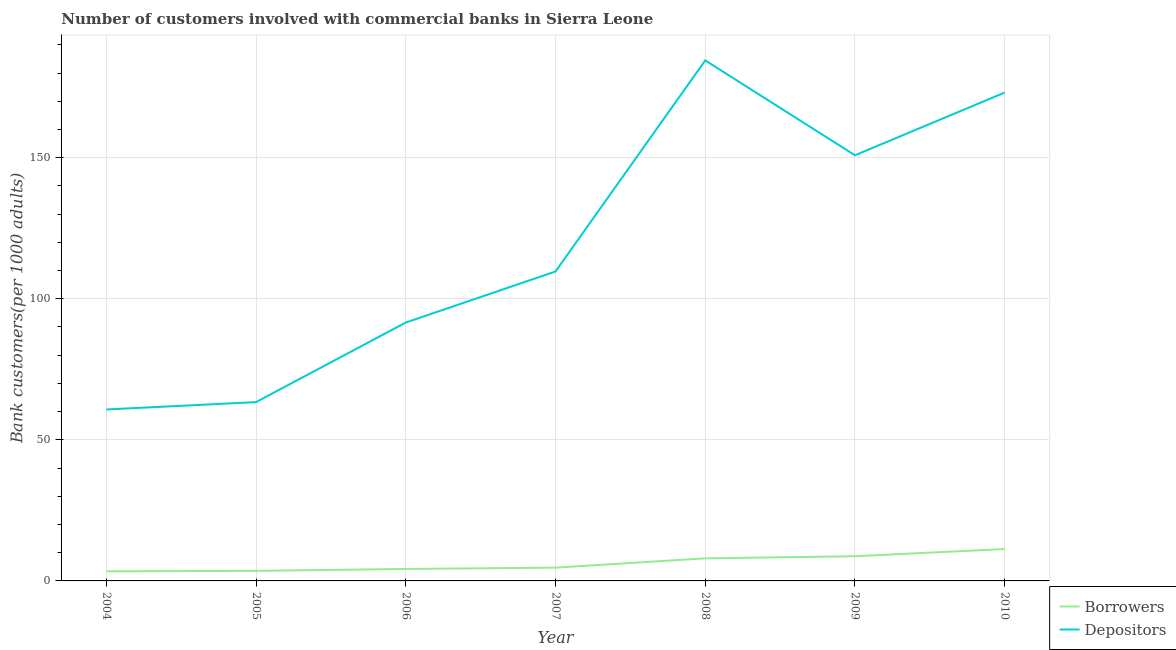Is the number of lines equal to the number of legend labels?
Your answer should be very brief. Yes. What is the number of depositors in 2004?
Your answer should be very brief. 60.76. Across all years, what is the maximum number of borrowers?
Your answer should be compact. 11.3. Across all years, what is the minimum number of depositors?
Keep it short and to the point. 60.76. In which year was the number of borrowers maximum?
Your answer should be compact. 2010. What is the total number of borrowers in the graph?
Your answer should be compact. 43.96. What is the difference between the number of borrowers in 2008 and that in 2009?
Give a very brief answer. -0.76. What is the difference between the number of borrowers in 2006 and the number of depositors in 2007?
Ensure brevity in your answer.  -105.42. What is the average number of borrowers per year?
Your answer should be very brief. 6.28. In the year 2007, what is the difference between the number of depositors and number of borrowers?
Keep it short and to the point. 104.96. In how many years, is the number of depositors greater than 60?
Keep it short and to the point. 7. What is the ratio of the number of borrowers in 2005 to that in 2007?
Give a very brief answer. 0.76. Is the number of depositors in 2004 less than that in 2007?
Offer a very short reply. Yes. What is the difference between the highest and the second highest number of borrowers?
Your answer should be compact. 2.54. What is the difference between the highest and the lowest number of borrowers?
Offer a very short reply. 7.9. Does the number of depositors monotonically increase over the years?
Make the answer very short. No. What is the difference between two consecutive major ticks on the Y-axis?
Your answer should be compact. 50. Are the values on the major ticks of Y-axis written in scientific E-notation?
Offer a very short reply. No. Does the graph contain grids?
Give a very brief answer. Yes. How are the legend labels stacked?
Your answer should be compact. Vertical. What is the title of the graph?
Your answer should be very brief. Number of customers involved with commercial banks in Sierra Leone. Does "Taxes on profits and capital gains" appear as one of the legend labels in the graph?
Your answer should be compact. No. What is the label or title of the Y-axis?
Make the answer very short. Bank customers(per 1000 adults). What is the Bank customers(per 1000 adults) in Borrowers in 2004?
Your answer should be compact. 3.4. What is the Bank customers(per 1000 adults) in Depositors in 2004?
Keep it short and to the point. 60.76. What is the Bank customers(per 1000 adults) of Borrowers in 2005?
Keep it short and to the point. 3.56. What is the Bank customers(per 1000 adults) of Depositors in 2005?
Offer a very short reply. 63.37. What is the Bank customers(per 1000 adults) of Borrowers in 2006?
Offer a terse response. 4.24. What is the Bank customers(per 1000 adults) of Depositors in 2006?
Offer a terse response. 91.57. What is the Bank customers(per 1000 adults) in Borrowers in 2007?
Your answer should be compact. 4.71. What is the Bank customers(per 1000 adults) of Depositors in 2007?
Offer a terse response. 109.66. What is the Bank customers(per 1000 adults) of Borrowers in 2008?
Provide a succinct answer. 7.99. What is the Bank customers(per 1000 adults) of Depositors in 2008?
Offer a very short reply. 184.46. What is the Bank customers(per 1000 adults) of Borrowers in 2009?
Give a very brief answer. 8.75. What is the Bank customers(per 1000 adults) of Depositors in 2009?
Offer a terse response. 150.85. What is the Bank customers(per 1000 adults) in Borrowers in 2010?
Your response must be concise. 11.3. What is the Bank customers(per 1000 adults) in Depositors in 2010?
Your response must be concise. 173.07. Across all years, what is the maximum Bank customers(per 1000 adults) of Borrowers?
Offer a terse response. 11.3. Across all years, what is the maximum Bank customers(per 1000 adults) of Depositors?
Make the answer very short. 184.46. Across all years, what is the minimum Bank customers(per 1000 adults) in Borrowers?
Make the answer very short. 3.4. Across all years, what is the minimum Bank customers(per 1000 adults) in Depositors?
Provide a short and direct response. 60.76. What is the total Bank customers(per 1000 adults) in Borrowers in the graph?
Ensure brevity in your answer.  43.96. What is the total Bank customers(per 1000 adults) in Depositors in the graph?
Your answer should be compact. 833.74. What is the difference between the Bank customers(per 1000 adults) of Borrowers in 2004 and that in 2005?
Provide a succinct answer. -0.16. What is the difference between the Bank customers(per 1000 adults) of Depositors in 2004 and that in 2005?
Provide a short and direct response. -2.6. What is the difference between the Bank customers(per 1000 adults) of Borrowers in 2004 and that in 2006?
Make the answer very short. -0.84. What is the difference between the Bank customers(per 1000 adults) in Depositors in 2004 and that in 2006?
Keep it short and to the point. -30.81. What is the difference between the Bank customers(per 1000 adults) in Borrowers in 2004 and that in 2007?
Your answer should be compact. -1.3. What is the difference between the Bank customers(per 1000 adults) in Depositors in 2004 and that in 2007?
Give a very brief answer. -48.9. What is the difference between the Bank customers(per 1000 adults) of Borrowers in 2004 and that in 2008?
Your answer should be very brief. -4.59. What is the difference between the Bank customers(per 1000 adults) in Depositors in 2004 and that in 2008?
Give a very brief answer. -123.7. What is the difference between the Bank customers(per 1000 adults) of Borrowers in 2004 and that in 2009?
Keep it short and to the point. -5.35. What is the difference between the Bank customers(per 1000 adults) in Depositors in 2004 and that in 2009?
Your response must be concise. -90.08. What is the difference between the Bank customers(per 1000 adults) of Borrowers in 2004 and that in 2010?
Your response must be concise. -7.9. What is the difference between the Bank customers(per 1000 adults) in Depositors in 2004 and that in 2010?
Offer a terse response. -112.31. What is the difference between the Bank customers(per 1000 adults) of Borrowers in 2005 and that in 2006?
Ensure brevity in your answer.  -0.68. What is the difference between the Bank customers(per 1000 adults) of Depositors in 2005 and that in 2006?
Make the answer very short. -28.2. What is the difference between the Bank customers(per 1000 adults) in Borrowers in 2005 and that in 2007?
Provide a succinct answer. -1.14. What is the difference between the Bank customers(per 1000 adults) of Depositors in 2005 and that in 2007?
Your answer should be compact. -46.3. What is the difference between the Bank customers(per 1000 adults) of Borrowers in 2005 and that in 2008?
Offer a very short reply. -4.43. What is the difference between the Bank customers(per 1000 adults) in Depositors in 2005 and that in 2008?
Give a very brief answer. -121.1. What is the difference between the Bank customers(per 1000 adults) in Borrowers in 2005 and that in 2009?
Your answer should be very brief. -5.19. What is the difference between the Bank customers(per 1000 adults) of Depositors in 2005 and that in 2009?
Your response must be concise. -87.48. What is the difference between the Bank customers(per 1000 adults) of Borrowers in 2005 and that in 2010?
Make the answer very short. -7.73. What is the difference between the Bank customers(per 1000 adults) in Depositors in 2005 and that in 2010?
Offer a terse response. -109.7. What is the difference between the Bank customers(per 1000 adults) in Borrowers in 2006 and that in 2007?
Provide a short and direct response. -0.47. What is the difference between the Bank customers(per 1000 adults) of Depositors in 2006 and that in 2007?
Provide a short and direct response. -18.09. What is the difference between the Bank customers(per 1000 adults) in Borrowers in 2006 and that in 2008?
Your response must be concise. -3.75. What is the difference between the Bank customers(per 1000 adults) in Depositors in 2006 and that in 2008?
Ensure brevity in your answer.  -92.89. What is the difference between the Bank customers(per 1000 adults) of Borrowers in 2006 and that in 2009?
Make the answer very short. -4.51. What is the difference between the Bank customers(per 1000 adults) of Depositors in 2006 and that in 2009?
Your answer should be very brief. -59.28. What is the difference between the Bank customers(per 1000 adults) in Borrowers in 2006 and that in 2010?
Provide a short and direct response. -7.06. What is the difference between the Bank customers(per 1000 adults) in Depositors in 2006 and that in 2010?
Offer a terse response. -81.5. What is the difference between the Bank customers(per 1000 adults) of Borrowers in 2007 and that in 2008?
Provide a short and direct response. -3.29. What is the difference between the Bank customers(per 1000 adults) in Depositors in 2007 and that in 2008?
Offer a terse response. -74.8. What is the difference between the Bank customers(per 1000 adults) of Borrowers in 2007 and that in 2009?
Your response must be concise. -4.05. What is the difference between the Bank customers(per 1000 adults) of Depositors in 2007 and that in 2009?
Your response must be concise. -41.18. What is the difference between the Bank customers(per 1000 adults) of Borrowers in 2007 and that in 2010?
Provide a short and direct response. -6.59. What is the difference between the Bank customers(per 1000 adults) in Depositors in 2007 and that in 2010?
Make the answer very short. -63.41. What is the difference between the Bank customers(per 1000 adults) of Borrowers in 2008 and that in 2009?
Ensure brevity in your answer.  -0.76. What is the difference between the Bank customers(per 1000 adults) of Depositors in 2008 and that in 2009?
Provide a succinct answer. 33.62. What is the difference between the Bank customers(per 1000 adults) in Borrowers in 2008 and that in 2010?
Your response must be concise. -3.3. What is the difference between the Bank customers(per 1000 adults) in Depositors in 2008 and that in 2010?
Provide a succinct answer. 11.39. What is the difference between the Bank customers(per 1000 adults) in Borrowers in 2009 and that in 2010?
Provide a succinct answer. -2.54. What is the difference between the Bank customers(per 1000 adults) in Depositors in 2009 and that in 2010?
Your response must be concise. -22.22. What is the difference between the Bank customers(per 1000 adults) of Borrowers in 2004 and the Bank customers(per 1000 adults) of Depositors in 2005?
Offer a terse response. -59.96. What is the difference between the Bank customers(per 1000 adults) in Borrowers in 2004 and the Bank customers(per 1000 adults) in Depositors in 2006?
Your answer should be compact. -88.17. What is the difference between the Bank customers(per 1000 adults) in Borrowers in 2004 and the Bank customers(per 1000 adults) in Depositors in 2007?
Offer a very short reply. -106.26. What is the difference between the Bank customers(per 1000 adults) in Borrowers in 2004 and the Bank customers(per 1000 adults) in Depositors in 2008?
Your response must be concise. -181.06. What is the difference between the Bank customers(per 1000 adults) of Borrowers in 2004 and the Bank customers(per 1000 adults) of Depositors in 2009?
Give a very brief answer. -147.44. What is the difference between the Bank customers(per 1000 adults) of Borrowers in 2004 and the Bank customers(per 1000 adults) of Depositors in 2010?
Your answer should be compact. -169.67. What is the difference between the Bank customers(per 1000 adults) of Borrowers in 2005 and the Bank customers(per 1000 adults) of Depositors in 2006?
Keep it short and to the point. -88. What is the difference between the Bank customers(per 1000 adults) in Borrowers in 2005 and the Bank customers(per 1000 adults) in Depositors in 2007?
Your response must be concise. -106.1. What is the difference between the Bank customers(per 1000 adults) in Borrowers in 2005 and the Bank customers(per 1000 adults) in Depositors in 2008?
Your answer should be compact. -180.9. What is the difference between the Bank customers(per 1000 adults) in Borrowers in 2005 and the Bank customers(per 1000 adults) in Depositors in 2009?
Make the answer very short. -147.28. What is the difference between the Bank customers(per 1000 adults) in Borrowers in 2005 and the Bank customers(per 1000 adults) in Depositors in 2010?
Keep it short and to the point. -169.5. What is the difference between the Bank customers(per 1000 adults) in Borrowers in 2006 and the Bank customers(per 1000 adults) in Depositors in 2007?
Provide a short and direct response. -105.42. What is the difference between the Bank customers(per 1000 adults) in Borrowers in 2006 and the Bank customers(per 1000 adults) in Depositors in 2008?
Give a very brief answer. -180.22. What is the difference between the Bank customers(per 1000 adults) in Borrowers in 2006 and the Bank customers(per 1000 adults) in Depositors in 2009?
Your answer should be compact. -146.61. What is the difference between the Bank customers(per 1000 adults) in Borrowers in 2006 and the Bank customers(per 1000 adults) in Depositors in 2010?
Provide a short and direct response. -168.83. What is the difference between the Bank customers(per 1000 adults) in Borrowers in 2007 and the Bank customers(per 1000 adults) in Depositors in 2008?
Offer a very short reply. -179.76. What is the difference between the Bank customers(per 1000 adults) in Borrowers in 2007 and the Bank customers(per 1000 adults) in Depositors in 2009?
Offer a terse response. -146.14. What is the difference between the Bank customers(per 1000 adults) in Borrowers in 2007 and the Bank customers(per 1000 adults) in Depositors in 2010?
Offer a terse response. -168.36. What is the difference between the Bank customers(per 1000 adults) of Borrowers in 2008 and the Bank customers(per 1000 adults) of Depositors in 2009?
Your answer should be compact. -142.85. What is the difference between the Bank customers(per 1000 adults) in Borrowers in 2008 and the Bank customers(per 1000 adults) in Depositors in 2010?
Your response must be concise. -165.08. What is the difference between the Bank customers(per 1000 adults) of Borrowers in 2009 and the Bank customers(per 1000 adults) of Depositors in 2010?
Provide a succinct answer. -164.32. What is the average Bank customers(per 1000 adults) of Borrowers per year?
Provide a succinct answer. 6.28. What is the average Bank customers(per 1000 adults) of Depositors per year?
Provide a short and direct response. 119.11. In the year 2004, what is the difference between the Bank customers(per 1000 adults) in Borrowers and Bank customers(per 1000 adults) in Depositors?
Give a very brief answer. -57.36. In the year 2005, what is the difference between the Bank customers(per 1000 adults) of Borrowers and Bank customers(per 1000 adults) of Depositors?
Ensure brevity in your answer.  -59.8. In the year 2006, what is the difference between the Bank customers(per 1000 adults) in Borrowers and Bank customers(per 1000 adults) in Depositors?
Give a very brief answer. -87.33. In the year 2007, what is the difference between the Bank customers(per 1000 adults) of Borrowers and Bank customers(per 1000 adults) of Depositors?
Provide a short and direct response. -104.96. In the year 2008, what is the difference between the Bank customers(per 1000 adults) of Borrowers and Bank customers(per 1000 adults) of Depositors?
Give a very brief answer. -176.47. In the year 2009, what is the difference between the Bank customers(per 1000 adults) in Borrowers and Bank customers(per 1000 adults) in Depositors?
Provide a succinct answer. -142.09. In the year 2010, what is the difference between the Bank customers(per 1000 adults) of Borrowers and Bank customers(per 1000 adults) of Depositors?
Give a very brief answer. -161.77. What is the ratio of the Bank customers(per 1000 adults) of Borrowers in 2004 to that in 2005?
Your answer should be compact. 0.95. What is the ratio of the Bank customers(per 1000 adults) in Depositors in 2004 to that in 2005?
Keep it short and to the point. 0.96. What is the ratio of the Bank customers(per 1000 adults) of Borrowers in 2004 to that in 2006?
Give a very brief answer. 0.8. What is the ratio of the Bank customers(per 1000 adults) of Depositors in 2004 to that in 2006?
Give a very brief answer. 0.66. What is the ratio of the Bank customers(per 1000 adults) in Borrowers in 2004 to that in 2007?
Keep it short and to the point. 0.72. What is the ratio of the Bank customers(per 1000 adults) of Depositors in 2004 to that in 2007?
Provide a short and direct response. 0.55. What is the ratio of the Bank customers(per 1000 adults) of Borrowers in 2004 to that in 2008?
Give a very brief answer. 0.43. What is the ratio of the Bank customers(per 1000 adults) of Depositors in 2004 to that in 2008?
Offer a very short reply. 0.33. What is the ratio of the Bank customers(per 1000 adults) of Borrowers in 2004 to that in 2009?
Give a very brief answer. 0.39. What is the ratio of the Bank customers(per 1000 adults) in Depositors in 2004 to that in 2009?
Offer a terse response. 0.4. What is the ratio of the Bank customers(per 1000 adults) of Borrowers in 2004 to that in 2010?
Provide a succinct answer. 0.3. What is the ratio of the Bank customers(per 1000 adults) of Depositors in 2004 to that in 2010?
Offer a very short reply. 0.35. What is the ratio of the Bank customers(per 1000 adults) in Borrowers in 2005 to that in 2006?
Your response must be concise. 0.84. What is the ratio of the Bank customers(per 1000 adults) in Depositors in 2005 to that in 2006?
Provide a succinct answer. 0.69. What is the ratio of the Bank customers(per 1000 adults) of Borrowers in 2005 to that in 2007?
Your answer should be very brief. 0.76. What is the ratio of the Bank customers(per 1000 adults) of Depositors in 2005 to that in 2007?
Your answer should be compact. 0.58. What is the ratio of the Bank customers(per 1000 adults) of Borrowers in 2005 to that in 2008?
Provide a short and direct response. 0.45. What is the ratio of the Bank customers(per 1000 adults) of Depositors in 2005 to that in 2008?
Ensure brevity in your answer.  0.34. What is the ratio of the Bank customers(per 1000 adults) of Borrowers in 2005 to that in 2009?
Offer a terse response. 0.41. What is the ratio of the Bank customers(per 1000 adults) of Depositors in 2005 to that in 2009?
Keep it short and to the point. 0.42. What is the ratio of the Bank customers(per 1000 adults) in Borrowers in 2005 to that in 2010?
Give a very brief answer. 0.32. What is the ratio of the Bank customers(per 1000 adults) in Depositors in 2005 to that in 2010?
Offer a very short reply. 0.37. What is the ratio of the Bank customers(per 1000 adults) in Borrowers in 2006 to that in 2007?
Keep it short and to the point. 0.9. What is the ratio of the Bank customers(per 1000 adults) of Depositors in 2006 to that in 2007?
Offer a very short reply. 0.83. What is the ratio of the Bank customers(per 1000 adults) of Borrowers in 2006 to that in 2008?
Your response must be concise. 0.53. What is the ratio of the Bank customers(per 1000 adults) in Depositors in 2006 to that in 2008?
Your answer should be compact. 0.5. What is the ratio of the Bank customers(per 1000 adults) of Borrowers in 2006 to that in 2009?
Keep it short and to the point. 0.48. What is the ratio of the Bank customers(per 1000 adults) of Depositors in 2006 to that in 2009?
Your answer should be compact. 0.61. What is the ratio of the Bank customers(per 1000 adults) of Borrowers in 2006 to that in 2010?
Offer a terse response. 0.38. What is the ratio of the Bank customers(per 1000 adults) of Depositors in 2006 to that in 2010?
Your answer should be compact. 0.53. What is the ratio of the Bank customers(per 1000 adults) of Borrowers in 2007 to that in 2008?
Offer a terse response. 0.59. What is the ratio of the Bank customers(per 1000 adults) of Depositors in 2007 to that in 2008?
Give a very brief answer. 0.59. What is the ratio of the Bank customers(per 1000 adults) of Borrowers in 2007 to that in 2009?
Your response must be concise. 0.54. What is the ratio of the Bank customers(per 1000 adults) of Depositors in 2007 to that in 2009?
Keep it short and to the point. 0.73. What is the ratio of the Bank customers(per 1000 adults) of Borrowers in 2007 to that in 2010?
Make the answer very short. 0.42. What is the ratio of the Bank customers(per 1000 adults) of Depositors in 2007 to that in 2010?
Ensure brevity in your answer.  0.63. What is the ratio of the Bank customers(per 1000 adults) in Borrowers in 2008 to that in 2009?
Keep it short and to the point. 0.91. What is the ratio of the Bank customers(per 1000 adults) of Depositors in 2008 to that in 2009?
Your answer should be compact. 1.22. What is the ratio of the Bank customers(per 1000 adults) in Borrowers in 2008 to that in 2010?
Offer a very short reply. 0.71. What is the ratio of the Bank customers(per 1000 adults) of Depositors in 2008 to that in 2010?
Offer a very short reply. 1.07. What is the ratio of the Bank customers(per 1000 adults) of Borrowers in 2009 to that in 2010?
Keep it short and to the point. 0.77. What is the ratio of the Bank customers(per 1000 adults) in Depositors in 2009 to that in 2010?
Your answer should be compact. 0.87. What is the difference between the highest and the second highest Bank customers(per 1000 adults) in Borrowers?
Provide a short and direct response. 2.54. What is the difference between the highest and the second highest Bank customers(per 1000 adults) in Depositors?
Offer a very short reply. 11.39. What is the difference between the highest and the lowest Bank customers(per 1000 adults) in Borrowers?
Keep it short and to the point. 7.9. What is the difference between the highest and the lowest Bank customers(per 1000 adults) of Depositors?
Keep it short and to the point. 123.7. 